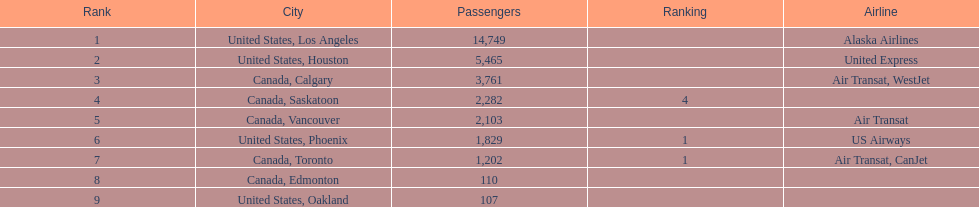How many cities from canada are on this list? 5. 